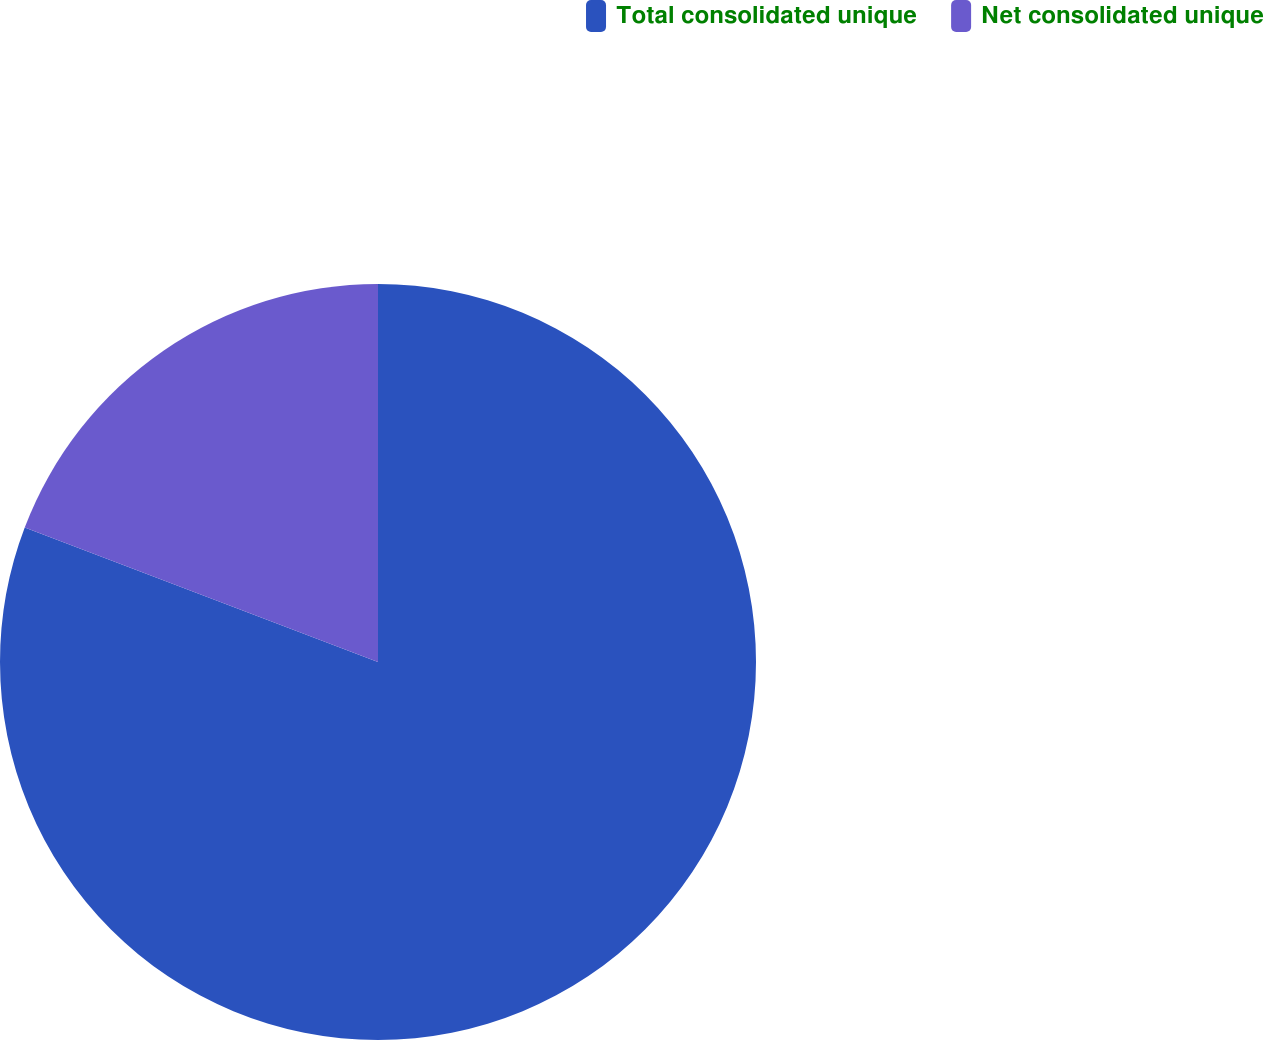Convert chart to OTSL. <chart><loc_0><loc_0><loc_500><loc_500><pie_chart><fcel>Total consolidated unique<fcel>Net consolidated unique<nl><fcel>80.79%<fcel>19.21%<nl></chart> 